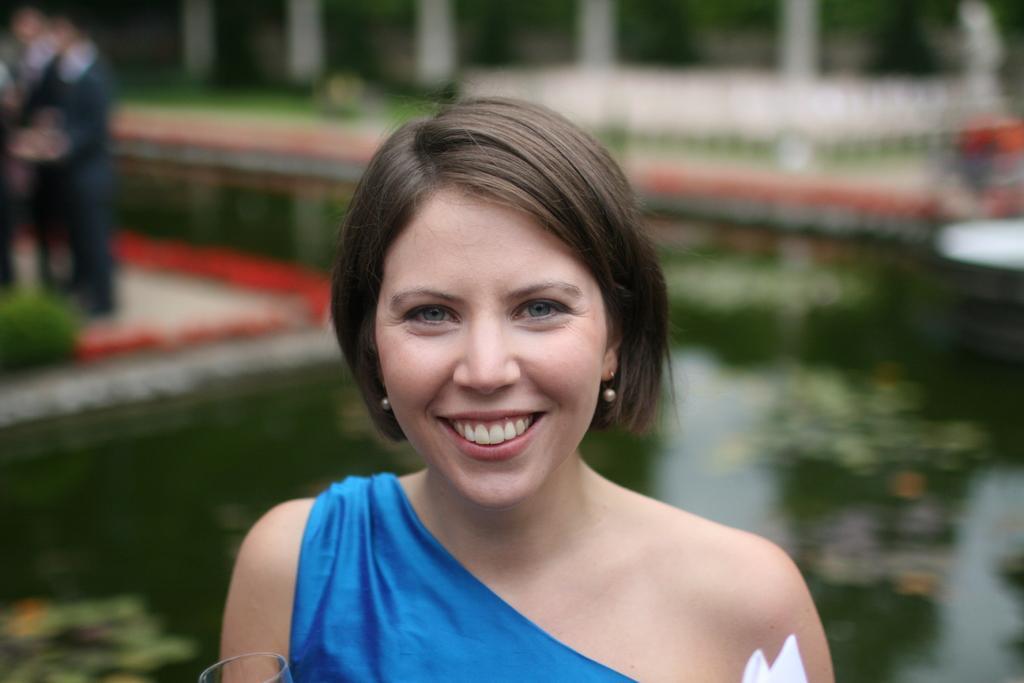Describe this image in one or two sentences. In this image in the front there is a woman smiling and in the background there are persons standing, there is water and there is grass on the ground and there are pillars and there is an object which is white in colour. 